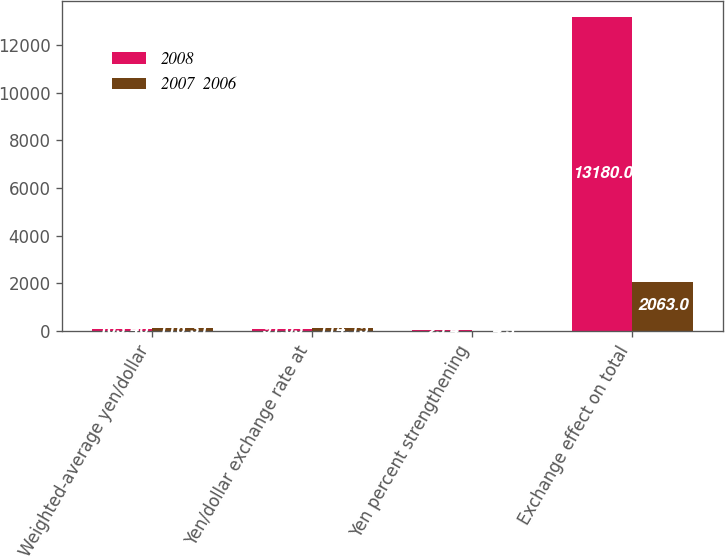<chart> <loc_0><loc_0><loc_500><loc_500><stacked_bar_chart><ecel><fcel>Weighted-average yen/dollar<fcel>Yen/dollar exchange rate at<fcel>Yen percent strengthening<fcel>Exchange effect on total<nl><fcel>2008<fcel>103.46<fcel>91.03<fcel>25.4<fcel>13180<nl><fcel>2007  2006<fcel>116.31<fcel>114.15<fcel>4.3<fcel>2063<nl></chart> 